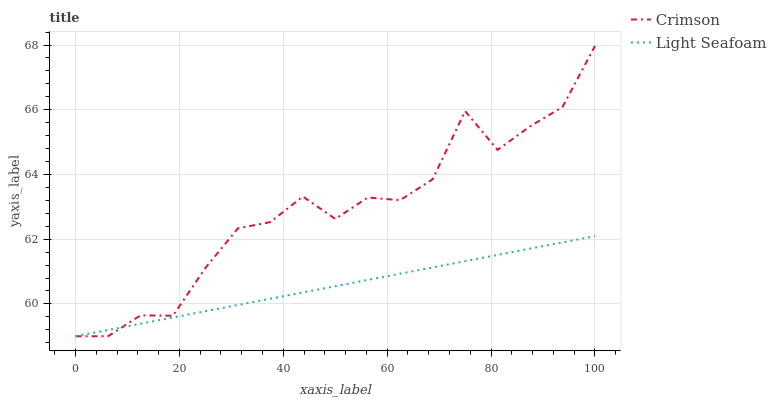Does Light Seafoam have the minimum area under the curve?
Answer yes or no. Yes. Does Crimson have the maximum area under the curve?
Answer yes or no. Yes. Does Light Seafoam have the maximum area under the curve?
Answer yes or no. No. Is Light Seafoam the smoothest?
Answer yes or no. Yes. Is Crimson the roughest?
Answer yes or no. Yes. Is Light Seafoam the roughest?
Answer yes or no. No. Does Crimson have the lowest value?
Answer yes or no. Yes. Does Crimson have the highest value?
Answer yes or no. Yes. Does Light Seafoam have the highest value?
Answer yes or no. No. Does Light Seafoam intersect Crimson?
Answer yes or no. Yes. Is Light Seafoam less than Crimson?
Answer yes or no. No. Is Light Seafoam greater than Crimson?
Answer yes or no. No. 